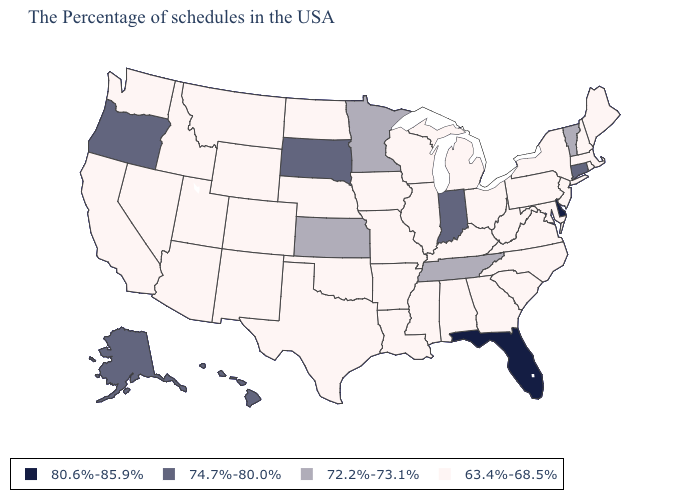Among the states that border Minnesota , which have the lowest value?
Give a very brief answer. Wisconsin, Iowa, North Dakota. What is the value of Louisiana?
Answer briefly. 63.4%-68.5%. What is the value of North Carolina?
Answer briefly. 63.4%-68.5%. Name the states that have a value in the range 80.6%-85.9%?
Be succinct. Delaware, Florida. Name the states that have a value in the range 72.2%-73.1%?
Answer briefly. Vermont, Tennessee, Minnesota, Kansas. What is the value of Vermont?
Concise answer only. 72.2%-73.1%. Does Minnesota have the lowest value in the MidWest?
Quick response, please. No. What is the value of Delaware?
Short answer required. 80.6%-85.9%. Name the states that have a value in the range 80.6%-85.9%?
Give a very brief answer. Delaware, Florida. Name the states that have a value in the range 74.7%-80.0%?
Answer briefly. Connecticut, Indiana, South Dakota, Oregon, Alaska, Hawaii. Name the states that have a value in the range 63.4%-68.5%?
Keep it brief. Maine, Massachusetts, Rhode Island, New Hampshire, New York, New Jersey, Maryland, Pennsylvania, Virginia, North Carolina, South Carolina, West Virginia, Ohio, Georgia, Michigan, Kentucky, Alabama, Wisconsin, Illinois, Mississippi, Louisiana, Missouri, Arkansas, Iowa, Nebraska, Oklahoma, Texas, North Dakota, Wyoming, Colorado, New Mexico, Utah, Montana, Arizona, Idaho, Nevada, California, Washington. Does Alaska have the lowest value in the USA?
Concise answer only. No. What is the value of Louisiana?
Give a very brief answer. 63.4%-68.5%. Is the legend a continuous bar?
Concise answer only. No. Does the map have missing data?
Answer briefly. No. 